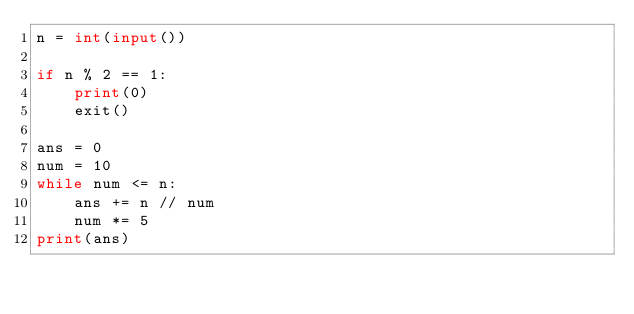Convert code to text. <code><loc_0><loc_0><loc_500><loc_500><_Python_>n = int(input())

if n % 2 == 1:
    print(0)
    exit()

ans = 0
num = 10
while num <= n:
    ans += n // num
    num *= 5
print(ans)</code> 